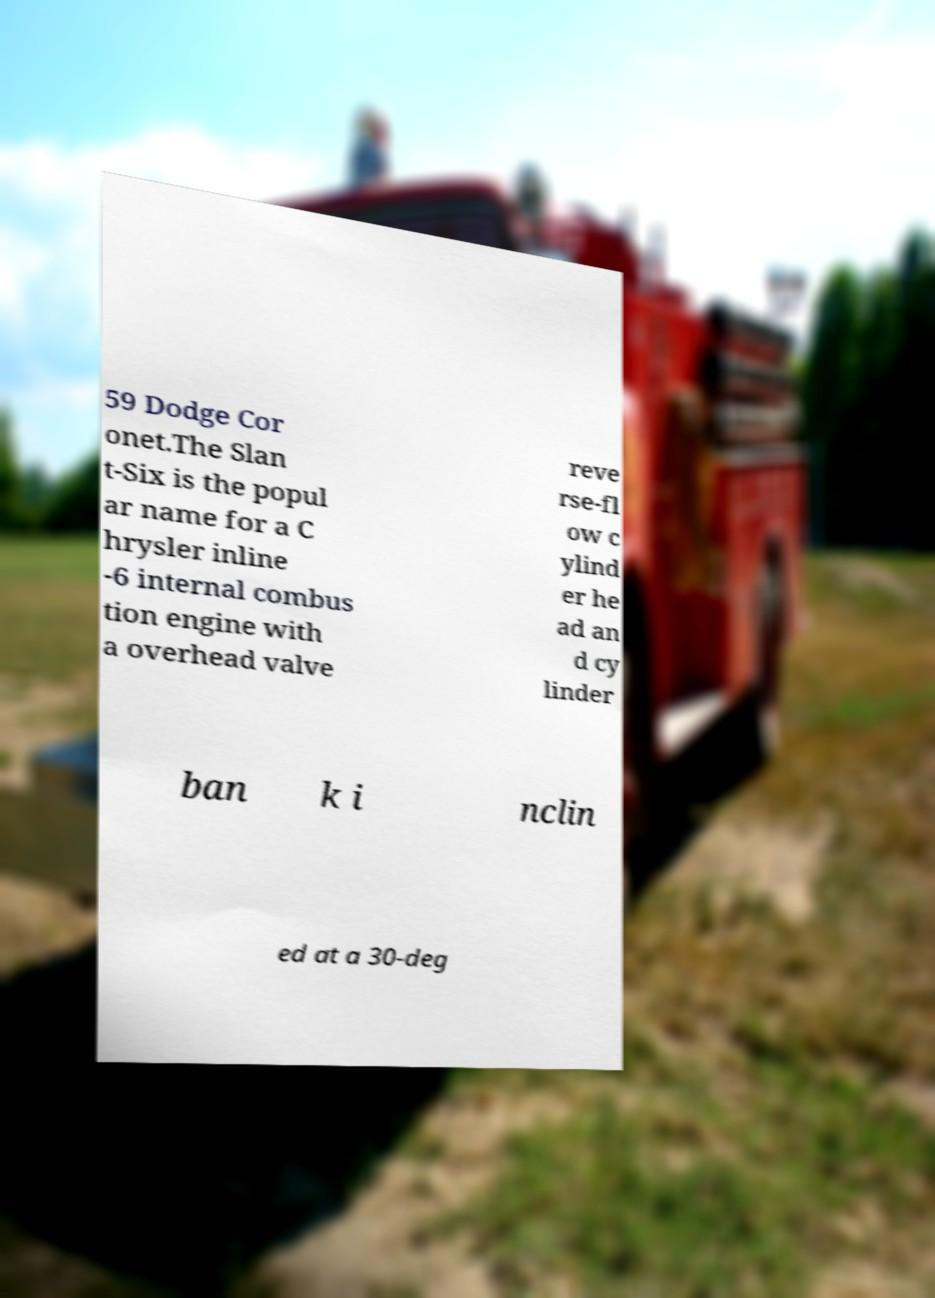I need the written content from this picture converted into text. Can you do that? 59 Dodge Cor onet.The Slan t-Six is the popul ar name for a C hrysler inline -6 internal combus tion engine with a overhead valve reve rse-fl ow c ylind er he ad an d cy linder ban k i nclin ed at a 30-deg 